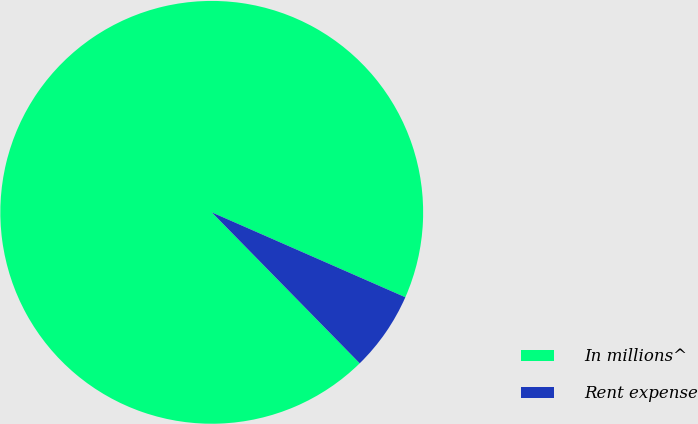Convert chart to OTSL. <chart><loc_0><loc_0><loc_500><loc_500><pie_chart><fcel>In millions^<fcel>Rent expense<nl><fcel>93.92%<fcel>6.08%<nl></chart> 